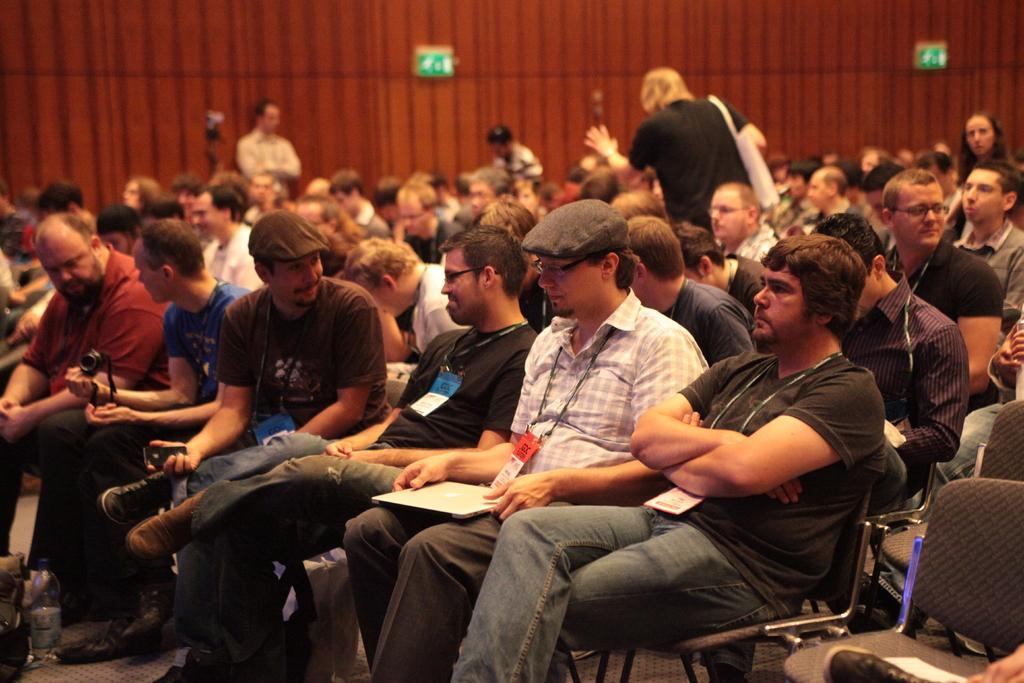Please provide a concise description of this image. In this picture we can see a few people sitting on the chair. We can see a person kept a laptop and holding it with his hands. There is another person wearing a bag and standing. We can see a few boards on a wooden background. 